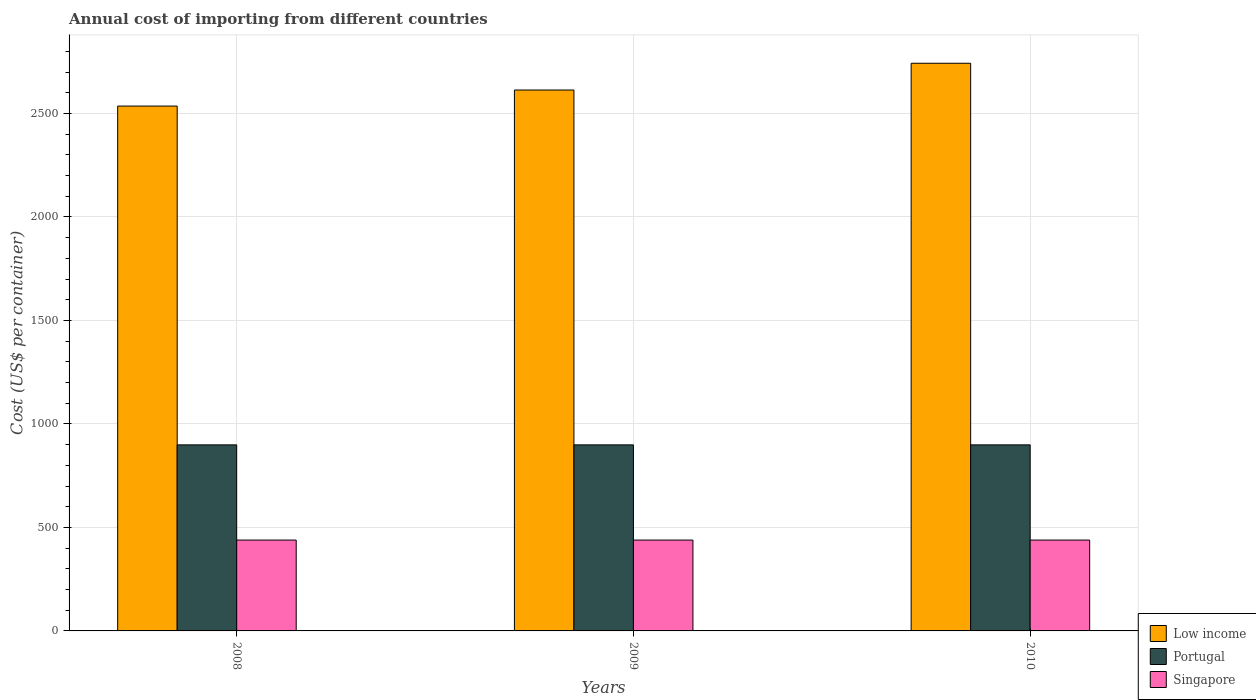How many groups of bars are there?
Make the answer very short. 3. Are the number of bars on each tick of the X-axis equal?
Provide a short and direct response. Yes. How many bars are there on the 1st tick from the left?
Give a very brief answer. 3. How many bars are there on the 1st tick from the right?
Ensure brevity in your answer.  3. What is the total annual cost of importing in Singapore in 2010?
Keep it short and to the point. 439. Across all years, what is the maximum total annual cost of importing in Singapore?
Provide a succinct answer. 439. Across all years, what is the minimum total annual cost of importing in Portugal?
Your response must be concise. 899. What is the total total annual cost of importing in Singapore in the graph?
Keep it short and to the point. 1317. What is the difference between the total annual cost of importing in Singapore in 2008 and that in 2009?
Ensure brevity in your answer.  0. What is the difference between the total annual cost of importing in Singapore in 2010 and the total annual cost of importing in Low income in 2009?
Provide a short and direct response. -2174.46. What is the average total annual cost of importing in Portugal per year?
Provide a short and direct response. 899. In the year 2009, what is the difference between the total annual cost of importing in Low income and total annual cost of importing in Singapore?
Make the answer very short. 2174.46. What is the ratio of the total annual cost of importing in Low income in 2009 to that in 2010?
Your response must be concise. 0.95. Is the total annual cost of importing in Portugal in 2009 less than that in 2010?
Offer a terse response. No. Is the difference between the total annual cost of importing in Low income in 2008 and 2009 greater than the difference between the total annual cost of importing in Singapore in 2008 and 2009?
Offer a terse response. No. What is the difference between the highest and the second highest total annual cost of importing in Portugal?
Provide a succinct answer. 0. In how many years, is the total annual cost of importing in Singapore greater than the average total annual cost of importing in Singapore taken over all years?
Ensure brevity in your answer.  0. Is the sum of the total annual cost of importing in Singapore in 2008 and 2010 greater than the maximum total annual cost of importing in Low income across all years?
Your response must be concise. No. How many bars are there?
Provide a short and direct response. 9. What is the difference between two consecutive major ticks on the Y-axis?
Keep it short and to the point. 500. Does the graph contain any zero values?
Ensure brevity in your answer.  No. Does the graph contain grids?
Offer a terse response. Yes. How many legend labels are there?
Your answer should be very brief. 3. How are the legend labels stacked?
Give a very brief answer. Vertical. What is the title of the graph?
Provide a succinct answer. Annual cost of importing from different countries. Does "Maldives" appear as one of the legend labels in the graph?
Your answer should be compact. No. What is the label or title of the Y-axis?
Your answer should be compact. Cost (US$ per container). What is the Cost (US$ per container) in Low income in 2008?
Give a very brief answer. 2535.93. What is the Cost (US$ per container) in Portugal in 2008?
Provide a succinct answer. 899. What is the Cost (US$ per container) of Singapore in 2008?
Your answer should be very brief. 439. What is the Cost (US$ per container) of Low income in 2009?
Your answer should be very brief. 2613.46. What is the Cost (US$ per container) of Portugal in 2009?
Make the answer very short. 899. What is the Cost (US$ per container) in Singapore in 2009?
Ensure brevity in your answer.  439. What is the Cost (US$ per container) in Low income in 2010?
Provide a succinct answer. 2742.82. What is the Cost (US$ per container) of Portugal in 2010?
Provide a short and direct response. 899. What is the Cost (US$ per container) in Singapore in 2010?
Offer a very short reply. 439. Across all years, what is the maximum Cost (US$ per container) in Low income?
Provide a succinct answer. 2742.82. Across all years, what is the maximum Cost (US$ per container) in Portugal?
Offer a very short reply. 899. Across all years, what is the maximum Cost (US$ per container) in Singapore?
Your response must be concise. 439. Across all years, what is the minimum Cost (US$ per container) in Low income?
Ensure brevity in your answer.  2535.93. Across all years, what is the minimum Cost (US$ per container) of Portugal?
Provide a short and direct response. 899. Across all years, what is the minimum Cost (US$ per container) in Singapore?
Keep it short and to the point. 439. What is the total Cost (US$ per container) in Low income in the graph?
Your answer should be very brief. 7892.21. What is the total Cost (US$ per container) of Portugal in the graph?
Offer a very short reply. 2697. What is the total Cost (US$ per container) in Singapore in the graph?
Provide a succinct answer. 1317. What is the difference between the Cost (US$ per container) in Low income in 2008 and that in 2009?
Your answer should be very brief. -77.54. What is the difference between the Cost (US$ per container) of Singapore in 2008 and that in 2009?
Your answer should be compact. 0. What is the difference between the Cost (US$ per container) of Low income in 2008 and that in 2010?
Provide a short and direct response. -206.89. What is the difference between the Cost (US$ per container) of Portugal in 2008 and that in 2010?
Provide a succinct answer. 0. What is the difference between the Cost (US$ per container) of Low income in 2009 and that in 2010?
Make the answer very short. -129.36. What is the difference between the Cost (US$ per container) in Portugal in 2009 and that in 2010?
Provide a short and direct response. 0. What is the difference between the Cost (US$ per container) in Singapore in 2009 and that in 2010?
Offer a very short reply. 0. What is the difference between the Cost (US$ per container) of Low income in 2008 and the Cost (US$ per container) of Portugal in 2009?
Your answer should be very brief. 1636.93. What is the difference between the Cost (US$ per container) of Low income in 2008 and the Cost (US$ per container) of Singapore in 2009?
Make the answer very short. 2096.93. What is the difference between the Cost (US$ per container) of Portugal in 2008 and the Cost (US$ per container) of Singapore in 2009?
Offer a terse response. 460. What is the difference between the Cost (US$ per container) of Low income in 2008 and the Cost (US$ per container) of Portugal in 2010?
Make the answer very short. 1636.93. What is the difference between the Cost (US$ per container) of Low income in 2008 and the Cost (US$ per container) of Singapore in 2010?
Make the answer very short. 2096.93. What is the difference between the Cost (US$ per container) of Portugal in 2008 and the Cost (US$ per container) of Singapore in 2010?
Your answer should be very brief. 460. What is the difference between the Cost (US$ per container) of Low income in 2009 and the Cost (US$ per container) of Portugal in 2010?
Make the answer very short. 1714.46. What is the difference between the Cost (US$ per container) in Low income in 2009 and the Cost (US$ per container) in Singapore in 2010?
Offer a very short reply. 2174.46. What is the difference between the Cost (US$ per container) of Portugal in 2009 and the Cost (US$ per container) of Singapore in 2010?
Your answer should be very brief. 460. What is the average Cost (US$ per container) of Low income per year?
Keep it short and to the point. 2630.74. What is the average Cost (US$ per container) in Portugal per year?
Provide a succinct answer. 899. What is the average Cost (US$ per container) in Singapore per year?
Provide a succinct answer. 439. In the year 2008, what is the difference between the Cost (US$ per container) in Low income and Cost (US$ per container) in Portugal?
Your response must be concise. 1636.93. In the year 2008, what is the difference between the Cost (US$ per container) in Low income and Cost (US$ per container) in Singapore?
Ensure brevity in your answer.  2096.93. In the year 2008, what is the difference between the Cost (US$ per container) of Portugal and Cost (US$ per container) of Singapore?
Offer a very short reply. 460. In the year 2009, what is the difference between the Cost (US$ per container) in Low income and Cost (US$ per container) in Portugal?
Ensure brevity in your answer.  1714.46. In the year 2009, what is the difference between the Cost (US$ per container) in Low income and Cost (US$ per container) in Singapore?
Make the answer very short. 2174.46. In the year 2009, what is the difference between the Cost (US$ per container) in Portugal and Cost (US$ per container) in Singapore?
Offer a very short reply. 460. In the year 2010, what is the difference between the Cost (US$ per container) in Low income and Cost (US$ per container) in Portugal?
Ensure brevity in your answer.  1843.82. In the year 2010, what is the difference between the Cost (US$ per container) in Low income and Cost (US$ per container) in Singapore?
Ensure brevity in your answer.  2303.82. In the year 2010, what is the difference between the Cost (US$ per container) in Portugal and Cost (US$ per container) in Singapore?
Provide a succinct answer. 460. What is the ratio of the Cost (US$ per container) of Low income in 2008 to that in 2009?
Make the answer very short. 0.97. What is the ratio of the Cost (US$ per container) of Singapore in 2008 to that in 2009?
Offer a terse response. 1. What is the ratio of the Cost (US$ per container) in Low income in 2008 to that in 2010?
Provide a succinct answer. 0.92. What is the ratio of the Cost (US$ per container) of Low income in 2009 to that in 2010?
Ensure brevity in your answer.  0.95. What is the difference between the highest and the second highest Cost (US$ per container) in Low income?
Keep it short and to the point. 129.36. What is the difference between the highest and the second highest Cost (US$ per container) of Portugal?
Make the answer very short. 0. What is the difference between the highest and the second highest Cost (US$ per container) of Singapore?
Give a very brief answer. 0. What is the difference between the highest and the lowest Cost (US$ per container) in Low income?
Offer a terse response. 206.89. What is the difference between the highest and the lowest Cost (US$ per container) in Portugal?
Keep it short and to the point. 0. What is the difference between the highest and the lowest Cost (US$ per container) of Singapore?
Offer a terse response. 0. 